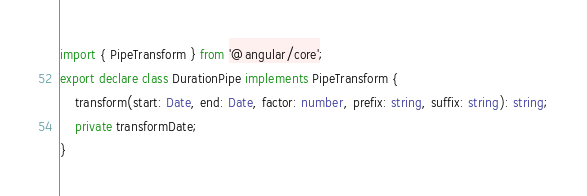<code> <loc_0><loc_0><loc_500><loc_500><_TypeScript_>import { PipeTransform } from '@angular/core';
export declare class DurationPipe implements PipeTransform {
    transform(start: Date, end: Date, factor: number, prefix: string, suffix: string): string;
    private transformDate;
}
</code> 